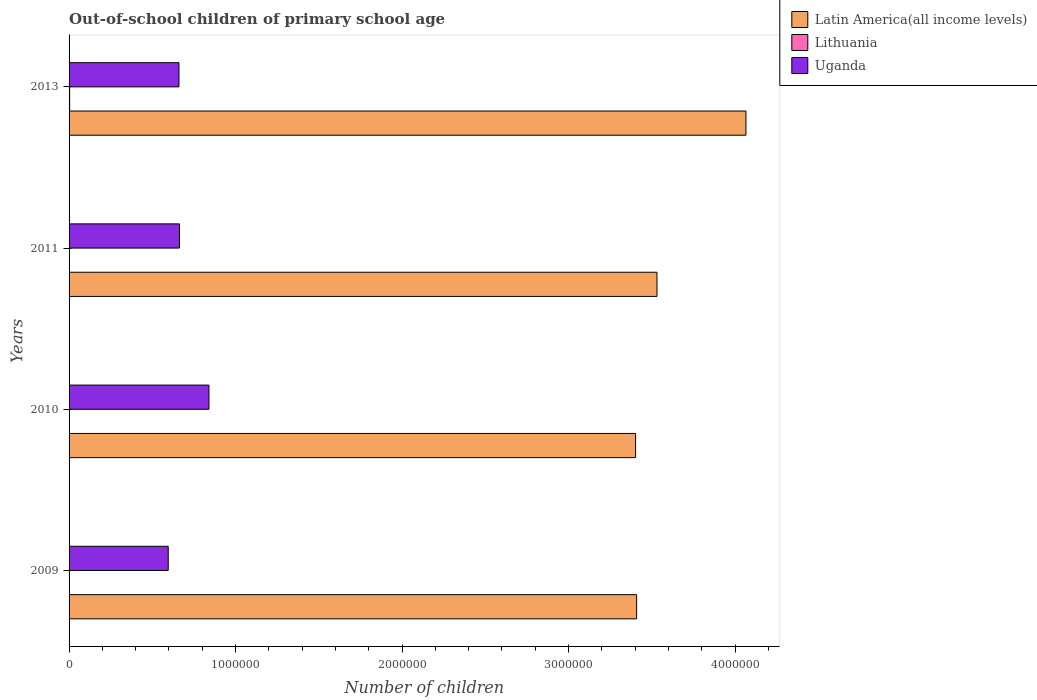How many different coloured bars are there?
Your response must be concise. 3. Are the number of bars on each tick of the Y-axis equal?
Provide a succinct answer. Yes. How many bars are there on the 3rd tick from the top?
Keep it short and to the point. 3. How many bars are there on the 1st tick from the bottom?
Your answer should be very brief. 3. What is the label of the 1st group of bars from the top?
Ensure brevity in your answer.  2013. In how many cases, is the number of bars for a given year not equal to the number of legend labels?
Provide a short and direct response. 0. What is the number of out-of-school children in Lithuania in 2009?
Your answer should be very brief. 1538. Across all years, what is the maximum number of out-of-school children in Latin America(all income levels)?
Make the answer very short. 4.07e+06. Across all years, what is the minimum number of out-of-school children in Lithuania?
Ensure brevity in your answer.  1333. In which year was the number of out-of-school children in Uganda maximum?
Provide a succinct answer. 2010. What is the total number of out-of-school children in Uganda in the graph?
Your answer should be very brief. 2.76e+06. What is the difference between the number of out-of-school children in Uganda in 2010 and that in 2011?
Provide a short and direct response. 1.77e+05. What is the difference between the number of out-of-school children in Uganda in 2009 and the number of out-of-school children in Lithuania in 2013?
Ensure brevity in your answer.  5.92e+05. What is the average number of out-of-school children in Uganda per year?
Your response must be concise. 6.90e+05. In the year 2013, what is the difference between the number of out-of-school children in Lithuania and number of out-of-school children in Uganda?
Your answer should be very brief. -6.57e+05. What is the ratio of the number of out-of-school children in Lithuania in 2010 to that in 2011?
Make the answer very short. 0.97. Is the number of out-of-school children in Lithuania in 2009 less than that in 2011?
Your response must be concise. No. Is the difference between the number of out-of-school children in Lithuania in 2011 and 2013 greater than the difference between the number of out-of-school children in Uganda in 2011 and 2013?
Ensure brevity in your answer.  No. What is the difference between the highest and the second highest number of out-of-school children in Lithuania?
Give a very brief answer. 1854. What is the difference between the highest and the lowest number of out-of-school children in Latin America(all income levels)?
Provide a succinct answer. 6.63e+05. In how many years, is the number of out-of-school children in Lithuania greater than the average number of out-of-school children in Lithuania taken over all years?
Make the answer very short. 1. What does the 1st bar from the top in 2013 represents?
Offer a very short reply. Uganda. What does the 1st bar from the bottom in 2013 represents?
Ensure brevity in your answer.  Latin America(all income levels). Are all the bars in the graph horizontal?
Ensure brevity in your answer.  Yes. How many years are there in the graph?
Provide a short and direct response. 4. Does the graph contain any zero values?
Ensure brevity in your answer.  No. Where does the legend appear in the graph?
Your answer should be very brief. Top right. How many legend labels are there?
Offer a terse response. 3. What is the title of the graph?
Your response must be concise. Out-of-school children of primary school age. What is the label or title of the X-axis?
Provide a succinct answer. Number of children. What is the label or title of the Y-axis?
Your answer should be compact. Years. What is the Number of children in Latin America(all income levels) in 2009?
Your answer should be compact. 3.41e+06. What is the Number of children of Lithuania in 2009?
Offer a terse response. 1538. What is the Number of children in Uganda in 2009?
Your answer should be very brief. 5.96e+05. What is the Number of children in Latin America(all income levels) in 2010?
Your answer should be compact. 3.40e+06. What is the Number of children in Lithuania in 2010?
Offer a terse response. 1333. What is the Number of children in Uganda in 2010?
Provide a succinct answer. 8.40e+05. What is the Number of children in Latin America(all income levels) in 2011?
Your answer should be very brief. 3.53e+06. What is the Number of children in Lithuania in 2011?
Give a very brief answer. 1381. What is the Number of children of Uganda in 2011?
Give a very brief answer. 6.63e+05. What is the Number of children of Latin America(all income levels) in 2013?
Your answer should be very brief. 4.07e+06. What is the Number of children of Lithuania in 2013?
Your response must be concise. 3392. What is the Number of children in Uganda in 2013?
Your answer should be compact. 6.60e+05. Across all years, what is the maximum Number of children in Latin America(all income levels)?
Provide a short and direct response. 4.07e+06. Across all years, what is the maximum Number of children of Lithuania?
Your answer should be very brief. 3392. Across all years, what is the maximum Number of children of Uganda?
Your response must be concise. 8.40e+05. Across all years, what is the minimum Number of children of Latin America(all income levels)?
Offer a terse response. 3.40e+06. Across all years, what is the minimum Number of children in Lithuania?
Provide a short and direct response. 1333. Across all years, what is the minimum Number of children in Uganda?
Your response must be concise. 5.96e+05. What is the total Number of children in Latin America(all income levels) in the graph?
Your response must be concise. 1.44e+07. What is the total Number of children of Lithuania in the graph?
Provide a succinct answer. 7644. What is the total Number of children of Uganda in the graph?
Your answer should be very brief. 2.76e+06. What is the difference between the Number of children of Latin America(all income levels) in 2009 and that in 2010?
Offer a terse response. 6138. What is the difference between the Number of children in Lithuania in 2009 and that in 2010?
Provide a short and direct response. 205. What is the difference between the Number of children in Uganda in 2009 and that in 2010?
Give a very brief answer. -2.45e+05. What is the difference between the Number of children in Latin America(all income levels) in 2009 and that in 2011?
Give a very brief answer. -1.22e+05. What is the difference between the Number of children in Lithuania in 2009 and that in 2011?
Your answer should be compact. 157. What is the difference between the Number of children of Uganda in 2009 and that in 2011?
Offer a very short reply. -6.74e+04. What is the difference between the Number of children of Latin America(all income levels) in 2009 and that in 2013?
Your response must be concise. -6.57e+05. What is the difference between the Number of children in Lithuania in 2009 and that in 2013?
Your response must be concise. -1854. What is the difference between the Number of children of Uganda in 2009 and that in 2013?
Your answer should be very brief. -6.45e+04. What is the difference between the Number of children in Latin America(all income levels) in 2010 and that in 2011?
Offer a terse response. -1.28e+05. What is the difference between the Number of children in Lithuania in 2010 and that in 2011?
Offer a very short reply. -48. What is the difference between the Number of children in Uganda in 2010 and that in 2011?
Make the answer very short. 1.77e+05. What is the difference between the Number of children of Latin America(all income levels) in 2010 and that in 2013?
Provide a short and direct response. -6.63e+05. What is the difference between the Number of children of Lithuania in 2010 and that in 2013?
Keep it short and to the point. -2059. What is the difference between the Number of children of Uganda in 2010 and that in 2013?
Provide a succinct answer. 1.80e+05. What is the difference between the Number of children in Latin America(all income levels) in 2011 and that in 2013?
Provide a short and direct response. -5.34e+05. What is the difference between the Number of children in Lithuania in 2011 and that in 2013?
Keep it short and to the point. -2011. What is the difference between the Number of children of Uganda in 2011 and that in 2013?
Your response must be concise. 2925. What is the difference between the Number of children in Latin America(all income levels) in 2009 and the Number of children in Lithuania in 2010?
Ensure brevity in your answer.  3.41e+06. What is the difference between the Number of children in Latin America(all income levels) in 2009 and the Number of children in Uganda in 2010?
Provide a succinct answer. 2.57e+06. What is the difference between the Number of children in Lithuania in 2009 and the Number of children in Uganda in 2010?
Make the answer very short. -8.39e+05. What is the difference between the Number of children in Latin America(all income levels) in 2009 and the Number of children in Lithuania in 2011?
Offer a very short reply. 3.41e+06. What is the difference between the Number of children in Latin America(all income levels) in 2009 and the Number of children in Uganda in 2011?
Keep it short and to the point. 2.75e+06. What is the difference between the Number of children in Lithuania in 2009 and the Number of children in Uganda in 2011?
Provide a succinct answer. -6.61e+05. What is the difference between the Number of children in Latin America(all income levels) in 2009 and the Number of children in Lithuania in 2013?
Your response must be concise. 3.41e+06. What is the difference between the Number of children in Latin America(all income levels) in 2009 and the Number of children in Uganda in 2013?
Give a very brief answer. 2.75e+06. What is the difference between the Number of children in Lithuania in 2009 and the Number of children in Uganda in 2013?
Your answer should be compact. -6.59e+05. What is the difference between the Number of children in Latin America(all income levels) in 2010 and the Number of children in Lithuania in 2011?
Provide a short and direct response. 3.40e+06. What is the difference between the Number of children of Latin America(all income levels) in 2010 and the Number of children of Uganda in 2011?
Keep it short and to the point. 2.74e+06. What is the difference between the Number of children of Lithuania in 2010 and the Number of children of Uganda in 2011?
Keep it short and to the point. -6.62e+05. What is the difference between the Number of children of Latin America(all income levels) in 2010 and the Number of children of Lithuania in 2013?
Provide a succinct answer. 3.40e+06. What is the difference between the Number of children of Latin America(all income levels) in 2010 and the Number of children of Uganda in 2013?
Your answer should be very brief. 2.74e+06. What is the difference between the Number of children in Lithuania in 2010 and the Number of children in Uganda in 2013?
Your response must be concise. -6.59e+05. What is the difference between the Number of children of Latin America(all income levels) in 2011 and the Number of children of Lithuania in 2013?
Offer a very short reply. 3.53e+06. What is the difference between the Number of children in Latin America(all income levels) in 2011 and the Number of children in Uganda in 2013?
Provide a succinct answer. 2.87e+06. What is the difference between the Number of children in Lithuania in 2011 and the Number of children in Uganda in 2013?
Offer a very short reply. -6.59e+05. What is the average Number of children in Latin America(all income levels) per year?
Make the answer very short. 3.60e+06. What is the average Number of children of Lithuania per year?
Your response must be concise. 1911. What is the average Number of children in Uganda per year?
Your response must be concise. 6.90e+05. In the year 2009, what is the difference between the Number of children in Latin America(all income levels) and Number of children in Lithuania?
Provide a short and direct response. 3.41e+06. In the year 2009, what is the difference between the Number of children of Latin America(all income levels) and Number of children of Uganda?
Offer a terse response. 2.81e+06. In the year 2009, what is the difference between the Number of children in Lithuania and Number of children in Uganda?
Keep it short and to the point. -5.94e+05. In the year 2010, what is the difference between the Number of children of Latin America(all income levels) and Number of children of Lithuania?
Your answer should be compact. 3.40e+06. In the year 2010, what is the difference between the Number of children of Latin America(all income levels) and Number of children of Uganda?
Offer a very short reply. 2.56e+06. In the year 2010, what is the difference between the Number of children in Lithuania and Number of children in Uganda?
Your response must be concise. -8.39e+05. In the year 2011, what is the difference between the Number of children of Latin America(all income levels) and Number of children of Lithuania?
Offer a terse response. 3.53e+06. In the year 2011, what is the difference between the Number of children of Latin America(all income levels) and Number of children of Uganda?
Make the answer very short. 2.87e+06. In the year 2011, what is the difference between the Number of children of Lithuania and Number of children of Uganda?
Your response must be concise. -6.62e+05. In the year 2013, what is the difference between the Number of children of Latin America(all income levels) and Number of children of Lithuania?
Offer a terse response. 4.06e+06. In the year 2013, what is the difference between the Number of children in Latin America(all income levels) and Number of children in Uganda?
Give a very brief answer. 3.41e+06. In the year 2013, what is the difference between the Number of children in Lithuania and Number of children in Uganda?
Your answer should be very brief. -6.57e+05. What is the ratio of the Number of children of Lithuania in 2009 to that in 2010?
Make the answer very short. 1.15. What is the ratio of the Number of children of Uganda in 2009 to that in 2010?
Offer a terse response. 0.71. What is the ratio of the Number of children of Latin America(all income levels) in 2009 to that in 2011?
Keep it short and to the point. 0.97. What is the ratio of the Number of children of Lithuania in 2009 to that in 2011?
Make the answer very short. 1.11. What is the ratio of the Number of children in Uganda in 2009 to that in 2011?
Provide a short and direct response. 0.9. What is the ratio of the Number of children in Latin America(all income levels) in 2009 to that in 2013?
Your answer should be very brief. 0.84. What is the ratio of the Number of children in Lithuania in 2009 to that in 2013?
Make the answer very short. 0.45. What is the ratio of the Number of children in Uganda in 2009 to that in 2013?
Your response must be concise. 0.9. What is the ratio of the Number of children of Latin America(all income levels) in 2010 to that in 2011?
Give a very brief answer. 0.96. What is the ratio of the Number of children of Lithuania in 2010 to that in 2011?
Give a very brief answer. 0.97. What is the ratio of the Number of children in Uganda in 2010 to that in 2011?
Offer a very short reply. 1.27. What is the ratio of the Number of children of Latin America(all income levels) in 2010 to that in 2013?
Offer a terse response. 0.84. What is the ratio of the Number of children in Lithuania in 2010 to that in 2013?
Make the answer very short. 0.39. What is the ratio of the Number of children in Uganda in 2010 to that in 2013?
Make the answer very short. 1.27. What is the ratio of the Number of children in Latin America(all income levels) in 2011 to that in 2013?
Keep it short and to the point. 0.87. What is the ratio of the Number of children of Lithuania in 2011 to that in 2013?
Your answer should be compact. 0.41. What is the difference between the highest and the second highest Number of children in Latin America(all income levels)?
Provide a succinct answer. 5.34e+05. What is the difference between the highest and the second highest Number of children in Lithuania?
Provide a succinct answer. 1854. What is the difference between the highest and the second highest Number of children of Uganda?
Make the answer very short. 1.77e+05. What is the difference between the highest and the lowest Number of children in Latin America(all income levels)?
Provide a succinct answer. 6.63e+05. What is the difference between the highest and the lowest Number of children of Lithuania?
Offer a very short reply. 2059. What is the difference between the highest and the lowest Number of children of Uganda?
Make the answer very short. 2.45e+05. 